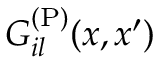Convert formula to latex. <formula><loc_0><loc_0><loc_500><loc_500>G _ { i l } ^ { ( P ) } ( x , x ^ { \prime } )</formula> 